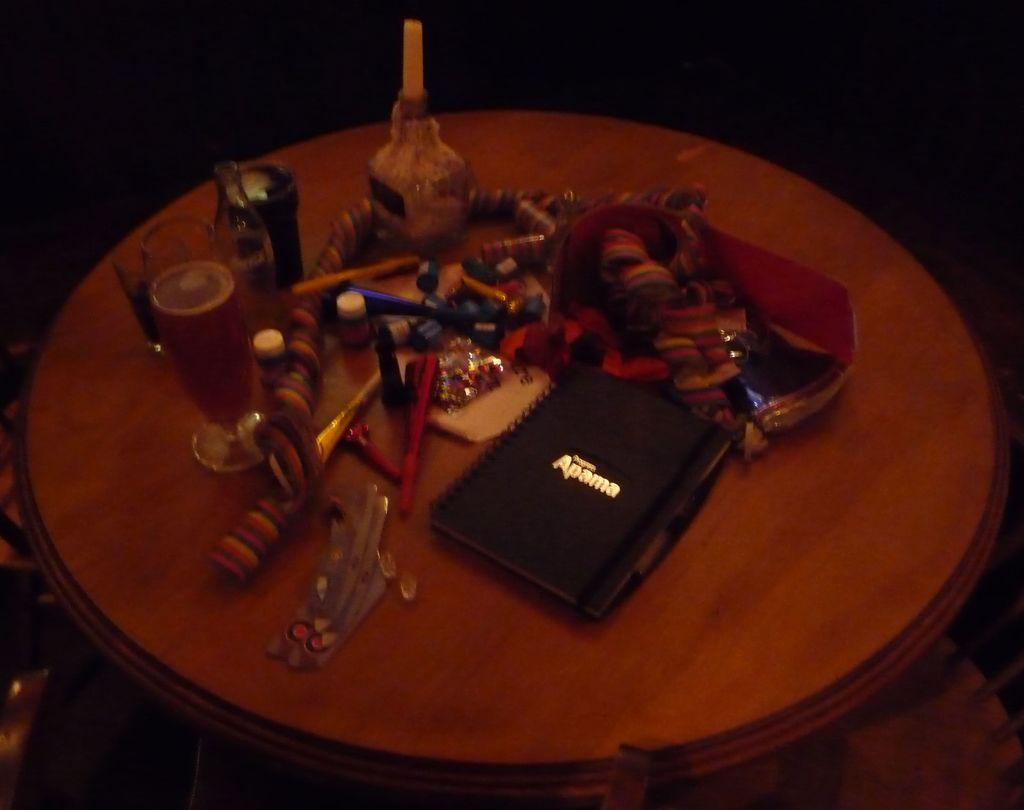Provide a one-sentence caption for the provided image. A black Apama notebook sits on a very cluttered table near a glass of beer. 